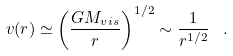<formula> <loc_0><loc_0><loc_500><loc_500>v ( r ) \simeq \left ( \frac { G M _ { v i s } } { r } \right ) ^ { 1 / 2 } \sim \frac { 1 } { r ^ { 1 / 2 } } \ \ .</formula> 